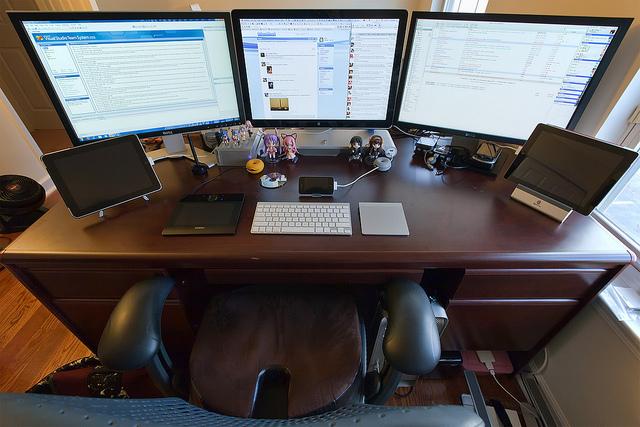Are these items carefully filed and sorted?
Concise answer only. Yes. How many monitors are being used?
Short answer required. 3. Is this a home office?
Answer briefly. Yes. How many drawers does the desk have?
Short answer required. 4. 